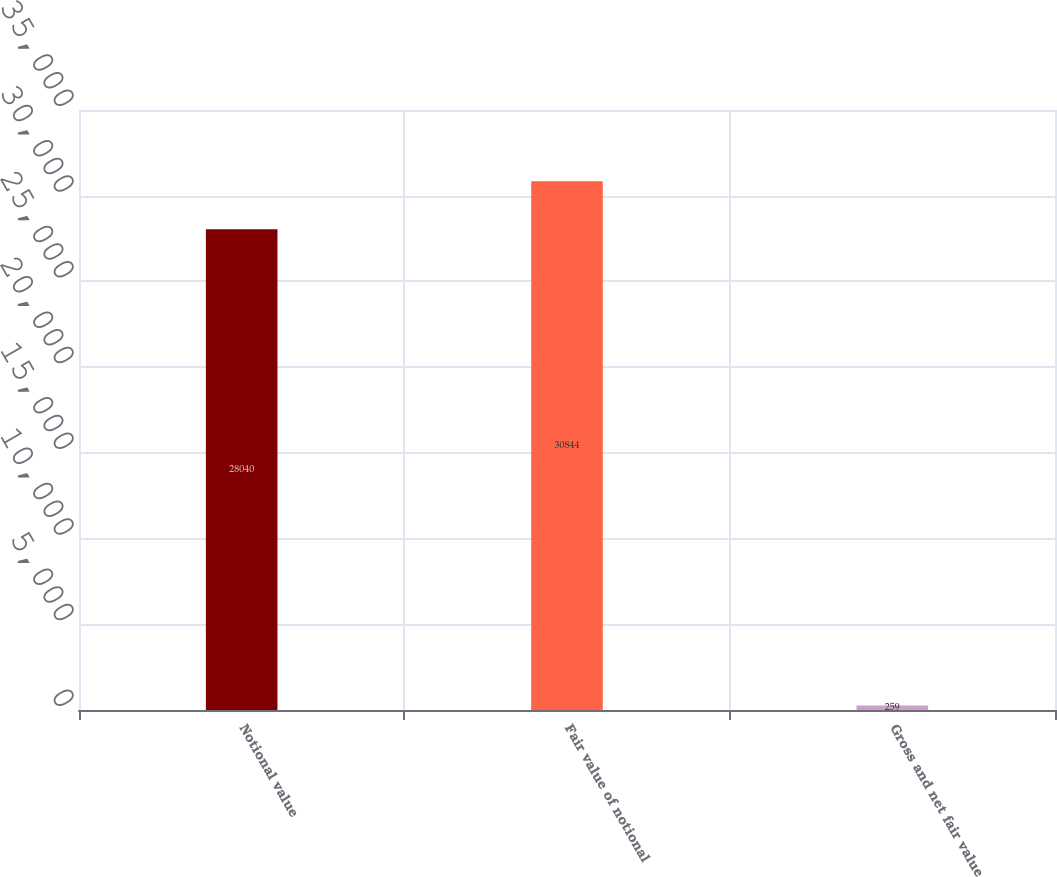Convert chart to OTSL. <chart><loc_0><loc_0><loc_500><loc_500><bar_chart><fcel>Notional value<fcel>Fair value of notional<fcel>Gross and net fair value<nl><fcel>28040<fcel>30844<fcel>259<nl></chart> 